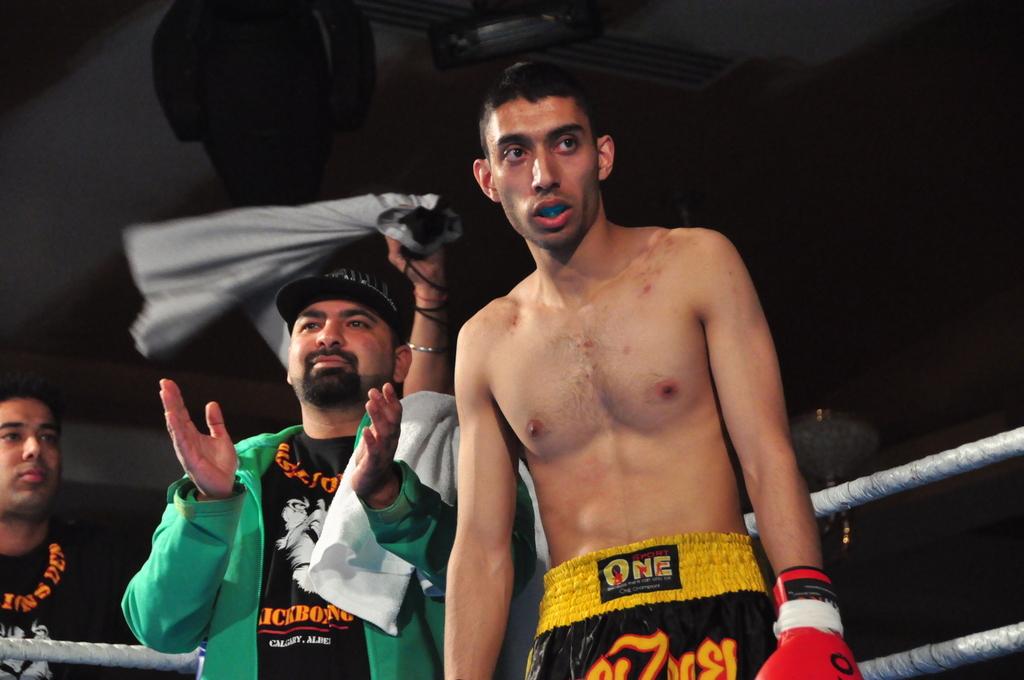What does the boxers shorts say?
Your response must be concise. One. 